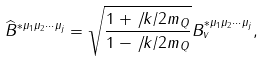<formula> <loc_0><loc_0><loc_500><loc_500>\widehat { B } ^ { * \mu _ { 1 } \mu _ { 2 } \cdots \mu _ { j } } = \sqrt { \frac { 1 + { \not \, k } / { 2 m _ { Q } } } { 1 - { \not \, k } / { 2 m _ { Q } } } } B ^ { * \mu _ { 1 } \mu _ { 2 } \cdots \mu _ { j } } _ { v } ,</formula> 